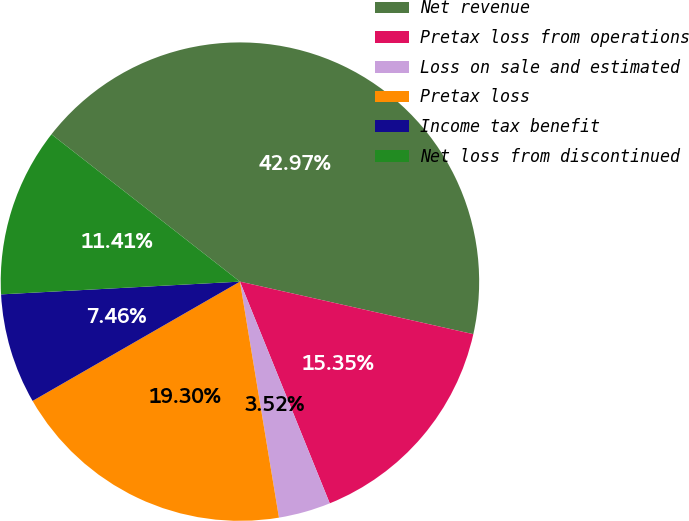Convert chart to OTSL. <chart><loc_0><loc_0><loc_500><loc_500><pie_chart><fcel>Net revenue<fcel>Pretax loss from operations<fcel>Loss on sale and estimated<fcel>Pretax loss<fcel>Income tax benefit<fcel>Net loss from discontinued<nl><fcel>42.97%<fcel>15.35%<fcel>3.52%<fcel>19.3%<fcel>7.46%<fcel>11.41%<nl></chart> 